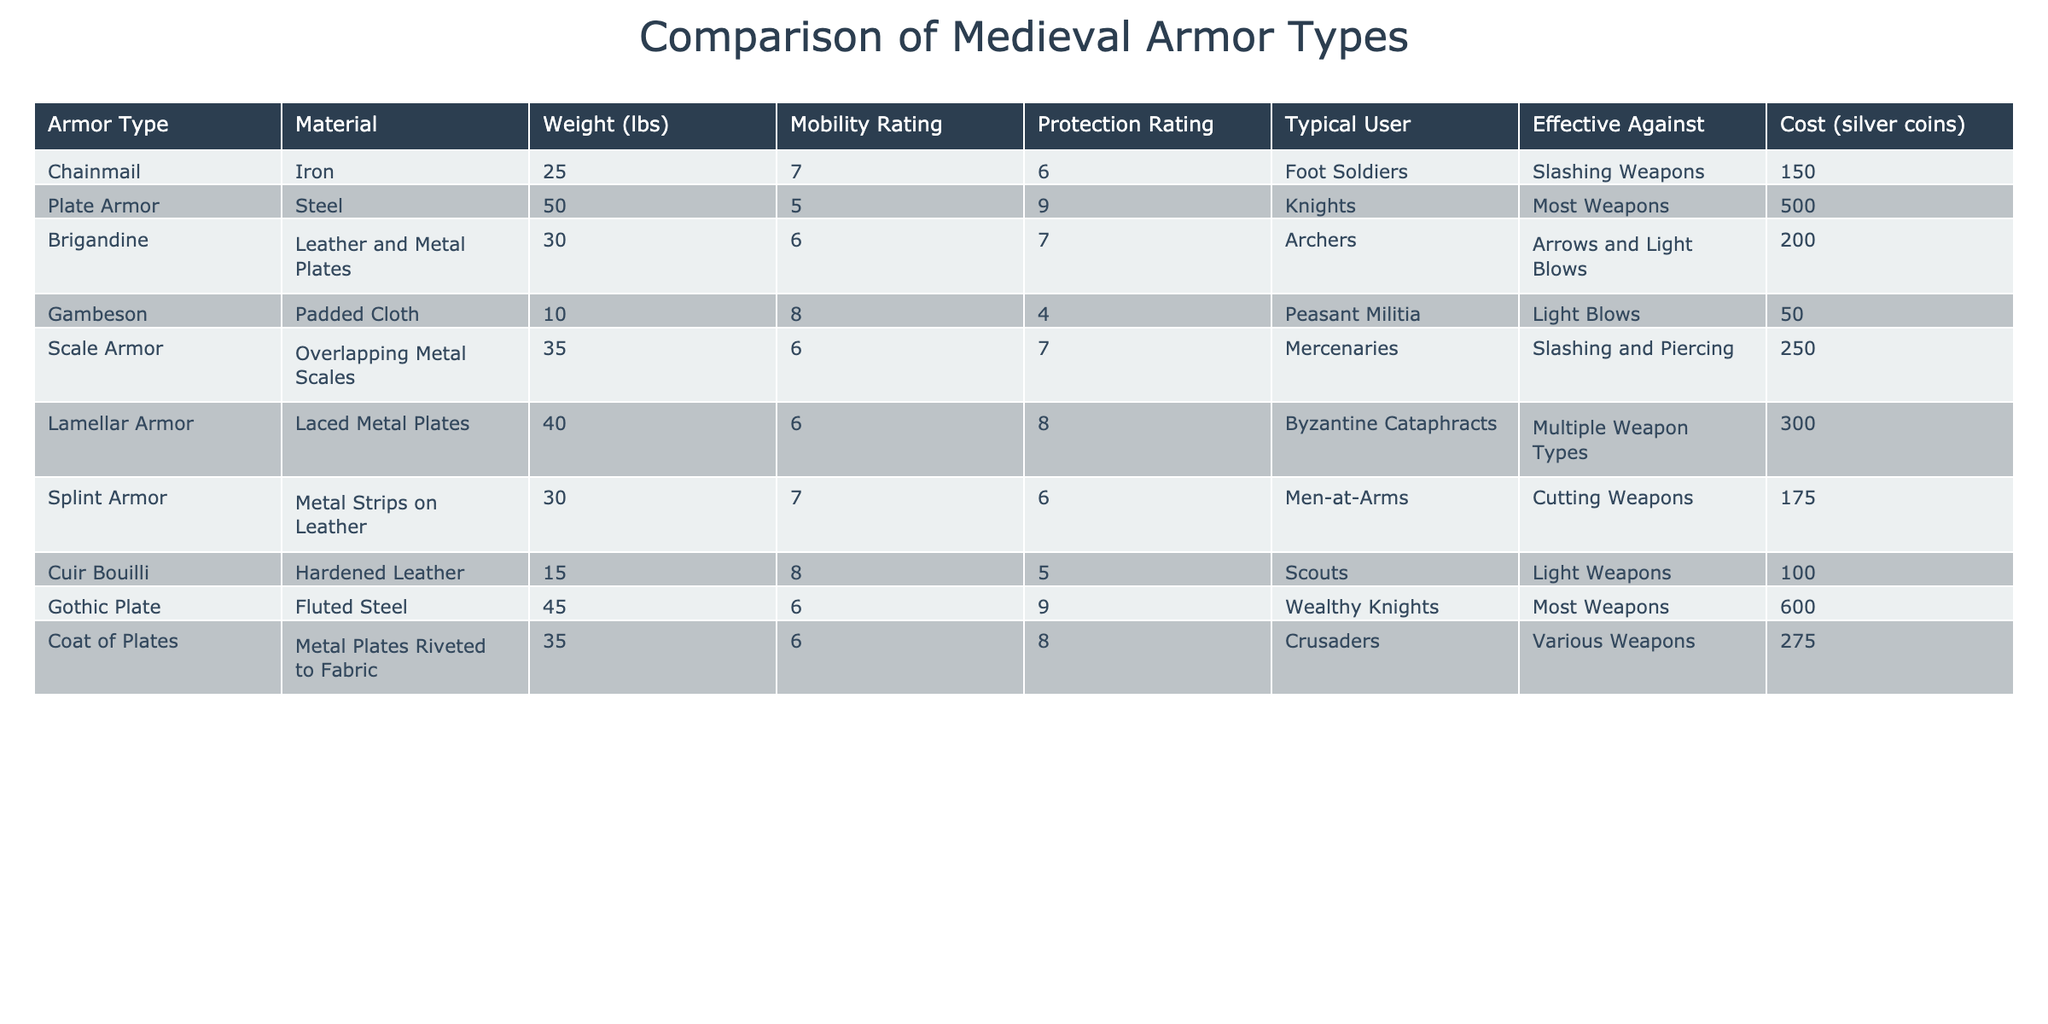What is the weight of Plate Armor? The table lists the weight of Plate Armor as 50 lbs, as indicated in the row for this armor type.
Answer: 50 lbs Which armor type has the highest mobility rating? By comparing the mobility ratings in the table, Gambeson and Cuir Bouilli both have a mobility rating of 8, which is the highest among the listed armor types.
Answer: Gambeson and Cuir Bouilli What is the protection rating difference between Plate Armor and Cuir Bouilli? Plate Armor has a protection rating of 9, while Cuir Bouilli has a rating of 5. The difference is calculated as 9 - 5 = 4.
Answer: 4 Is the Cost of Scale Armor higher than that of Brigandine? The cost of Scale Armor is 250 silver coins, while Brigandine costs 200 silver coins. Since 250 > 200, the answer is yes.
Answer: Yes Which armor type is effective against light blows and costs the least? Looking at the table, Gambeson is effective against light blows and has a cost of 50 silver coins, which is the lowest cost among all armor types effective against light blows.
Answer: Gambeson What is the average cost of the armor types listed? To find the average cost, add the costs: 150 + 500 + 200 + 50 + 250 + 300 + 175 + 100 + 600 + 275 = 2400. There are 10 armor types, so the average is 2400 / 10 = 240 silver coins.
Answer: 240 silver coins Which armor type provides protection against "Most Weapons" and has a cost greater than 500 silver coins? The only armor type providing protection against "Most Weapons" is Plate Armor, which costs 500 silver coins. Since it is equal to 500 and not greater, there's no armor meeting this criterion.
Answer: No Which armor types are typically used by foot soldiers and archers? The armor type Chainmail is used by foot soldiers, and Brigandine is used by archers, as indicated in the Typical User column of the table.
Answer: Chainmail and Brigandine What armor type offers better protection: Scale Armor or Splint Armor? Scale Armor has a protection rating of 7, while Splint Armor has a rating of 6. Since 7 > 6, Scale Armor offers better protection.
Answer: Scale Armor What is the weight difference between Gothic Plate and Chainmail? Gothic Plate weighs 45 lbs and Chainmail weighs 25 lbs. The difference is calculated as 45 - 25 = 20 lbs.
Answer: 20 lbs 